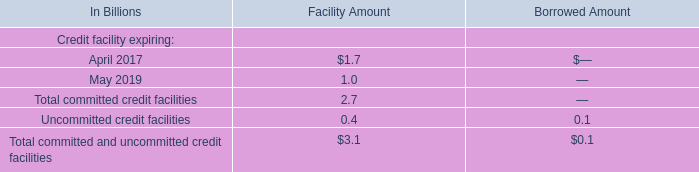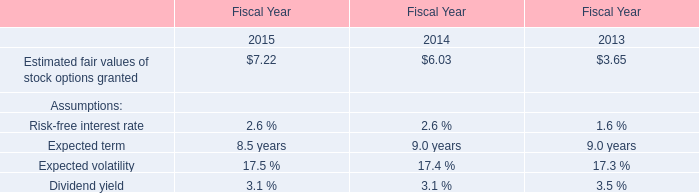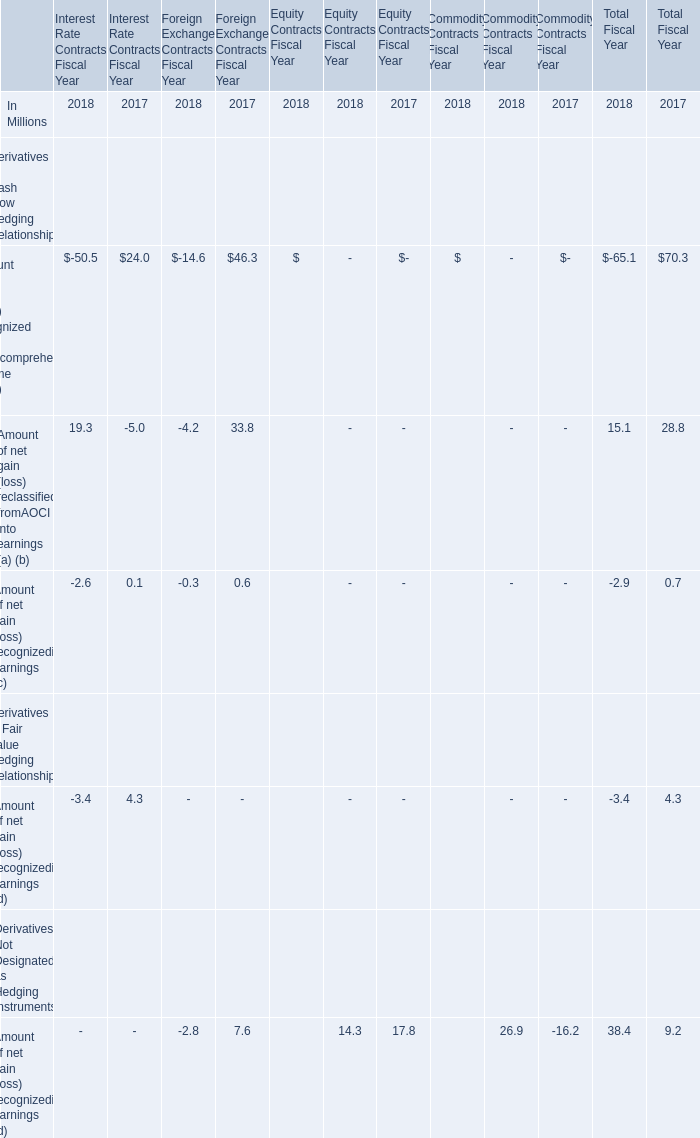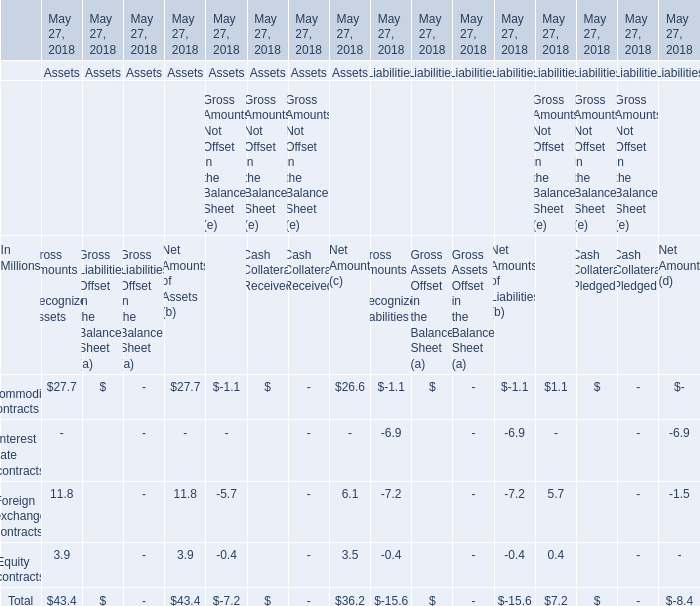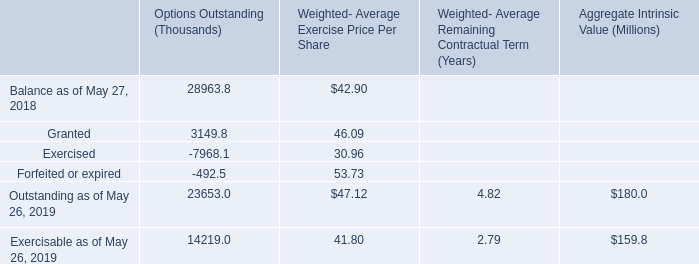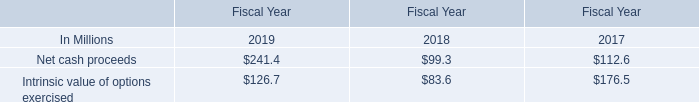What was the total amount of Net Amount in terms of Assets greater than 10 million at May 27, 2018? (in million) 
Answer: 26.6. 